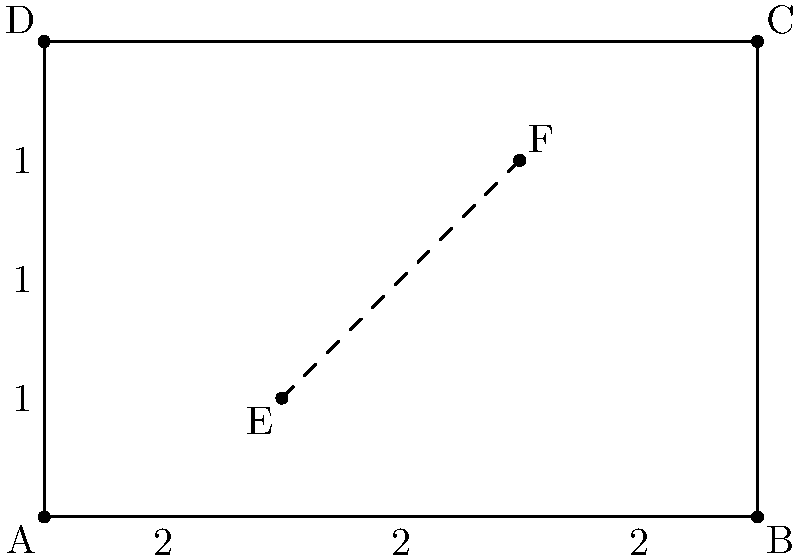As the police captain, you're tasked with optimizing patrol routes in a rectangular district. The district is represented by a 6x4 grid, where each unit represents 1 km. A diagonal patrol route is proposed from point E (2,1) to point F (4,3). Calculate the length of this patrol route to the nearest tenth of a kilometer. To solve this problem, we'll use the distance formula derived from the Pythagorean theorem:

1) The distance formula is:
   $$d = \sqrt{(x_2-x_1)^2 + (y_2-y_1)^2}$$

2) We have two points:
   E (2,1) and F (4,3)

3) Let's identify our x and y coordinates:
   $x_1 = 2$, $y_1 = 1$
   $x_2 = 4$, $y_2 = 3$

4) Now, let's substitute these into our formula:
   $$d = \sqrt{(4-2)^2 + (3-1)^2}$$

5) Simplify inside the parentheses:
   $$d = \sqrt{2^2 + 2^2}$$

6) Calculate the squares:
   $$d = \sqrt{4 + 4}$$

7) Add under the square root:
   $$d = \sqrt{8}$$

8) Simplify the square root:
   $$d = 2\sqrt{2}$$

9) Use a calculator to get the decimal approximation:
   $$d \approx 2.8284$$

10) Rounding to the nearest tenth:
    $$d \approx 2.8 \text{ km}$$

Therefore, the length of the patrol route is approximately 2.8 km.
Answer: 2.8 km 